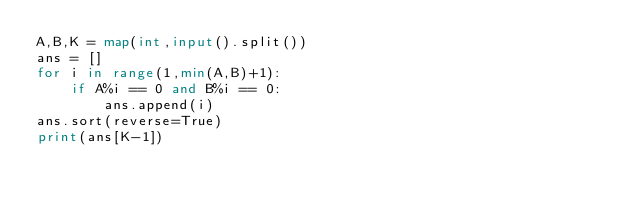<code> <loc_0><loc_0><loc_500><loc_500><_Python_>A,B,K = map(int,input().split())
ans = []
for i in range(1,min(A,B)+1):
    if A%i == 0 and B%i == 0:
        ans.append(i)
ans.sort(reverse=True)
print(ans[K-1])
</code> 